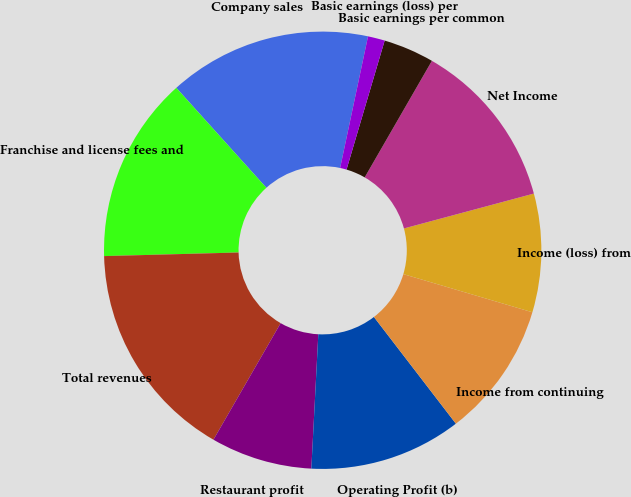Convert chart to OTSL. <chart><loc_0><loc_0><loc_500><loc_500><pie_chart><fcel>Company sales<fcel>Franchise and license fees and<fcel>Total revenues<fcel>Restaurant profit<fcel>Operating Profit (b)<fcel>Income from continuing<fcel>Income (loss) from<fcel>Net Income<fcel>Basic earnings per common<fcel>Basic earnings (loss) per<nl><fcel>15.0%<fcel>13.75%<fcel>16.25%<fcel>7.5%<fcel>11.25%<fcel>10.0%<fcel>8.75%<fcel>12.5%<fcel>3.75%<fcel>1.25%<nl></chart> 